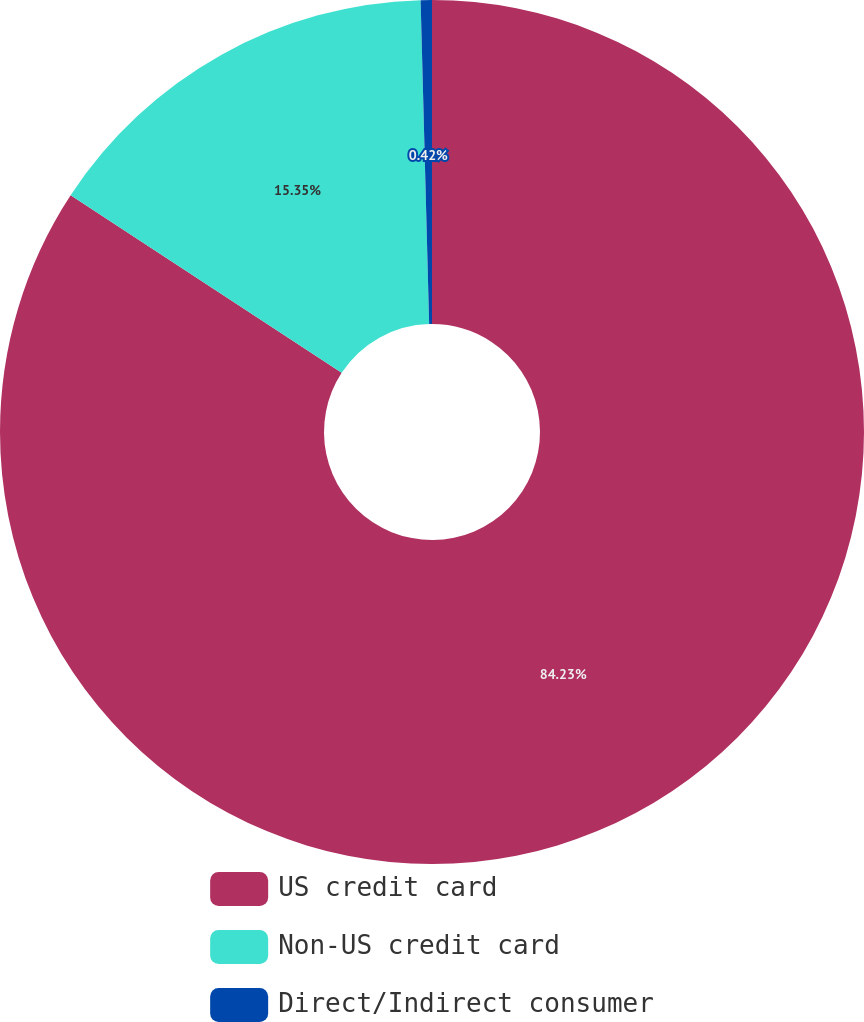Convert chart to OTSL. <chart><loc_0><loc_0><loc_500><loc_500><pie_chart><fcel>US credit card<fcel>Non-US credit card<fcel>Direct/Indirect consumer<nl><fcel>84.23%<fcel>15.35%<fcel>0.42%<nl></chart> 